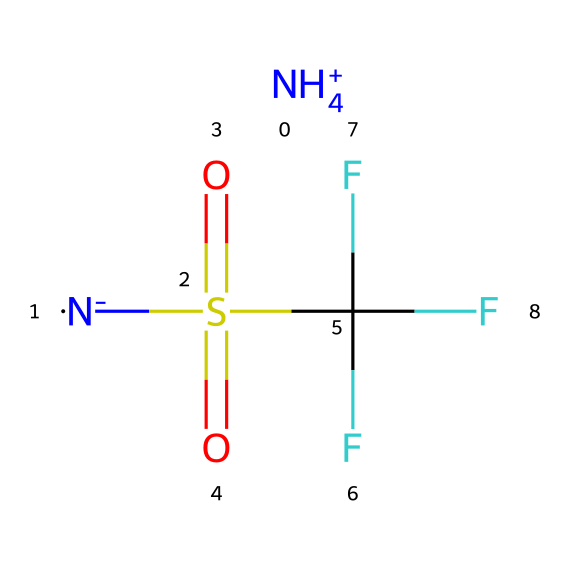What is the cationic component in this ionic liquid? The structure indicates that the cation is derived from ammonium, as it shows a positively charged nitrogen (NH4+).
Answer: ammonium How many carbon atoms are in the molecular structure? By interpreting the SMILES, there is one carbon atom present in the sulfonium-like structure.
Answer: 1 What functional groups are present in this ionic liquid? Analyzing the structure, we see the presence of a sulfonyl group (S(=O)(=O)) and a trifluoromethyl group (C(F)(F)F) indicating specific functional groups.
Answer: sulfonyl and trifluoromethyl What type of ion is represented by the [N-] part of the SMILES? The [N-] part represents an anionic component, typically a nitrogen-containing species that carries a negative charge, contributing to ionic characteristics.
Answer: anion Does this ionic liquid have fluorine atoms in its structure? The presence of C(F)(F)F clearly indicates the presence of three fluorine atoms bonded to the carbon.
Answer: yes How does the presence of the sulfonyl group affect the properties of this ionic liquid? The sulfonyl group is known to enhance the solubility of the ionic liquid in organic solvents and can affect its viscosity and conductivity.
Answer: enhances solubility In total, how many atoms are there in the ionic liquid? By counting all atoms present in the SMILES, we find 7 atoms: 4 hydrogen, 1 nitrogen, 1 sulfur, and 1 carbon.
Answer: 7 